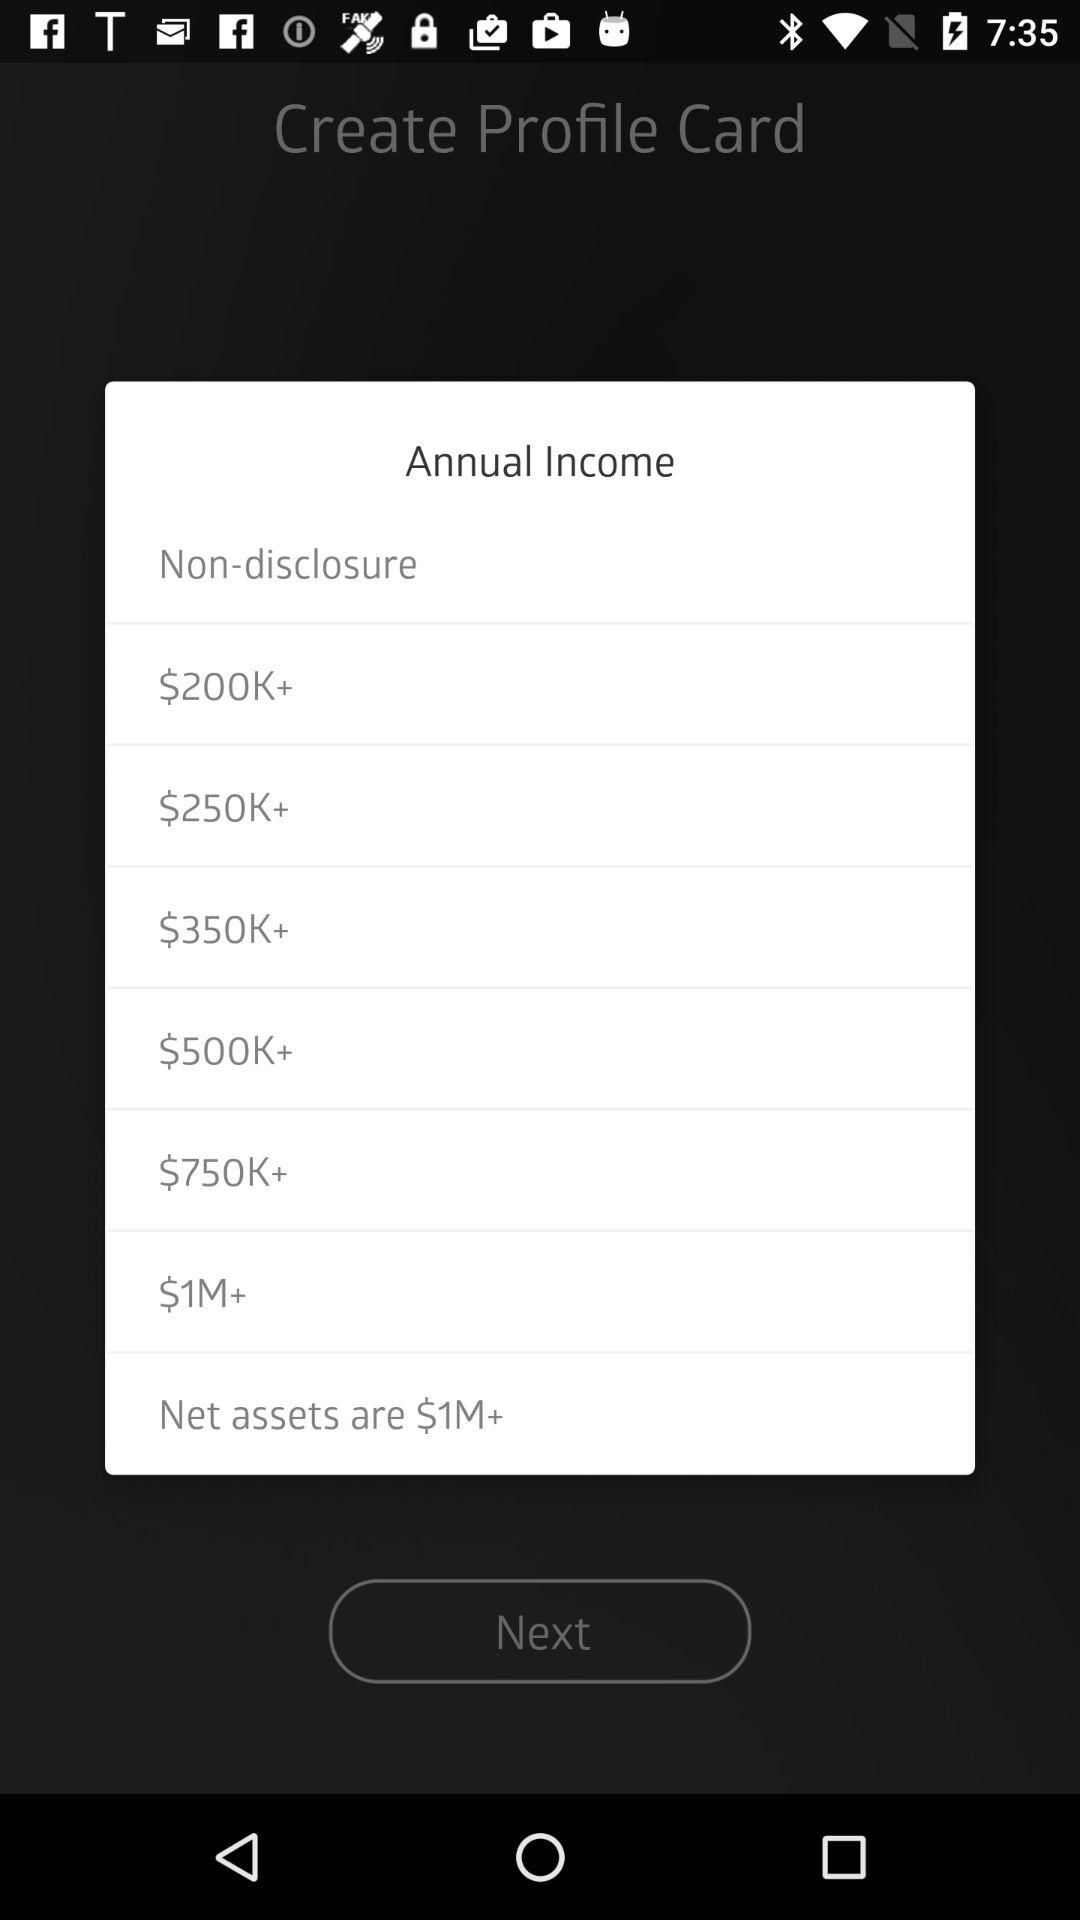How many income options are there?
Answer the question using a single word or phrase. 8 